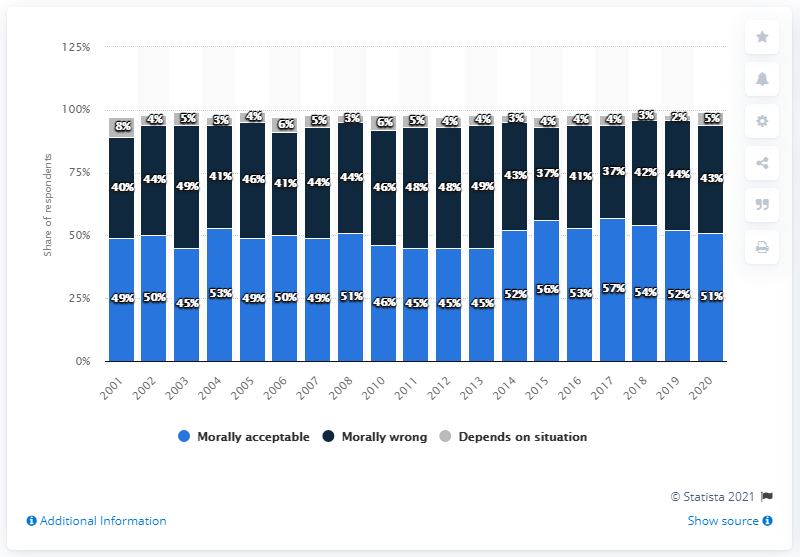Mention a couple of crucial points in this snapshot. In 2001, it was deemed acceptable by 49% of people for doctors to assist in suicide. The minimum value for the percentage of people deemed acceptable was in the years [2003, 2011, 2012, 2013]. 